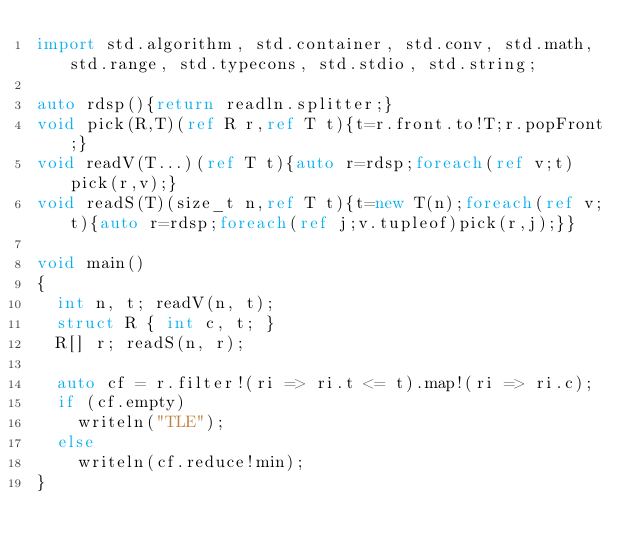<code> <loc_0><loc_0><loc_500><loc_500><_D_>import std.algorithm, std.container, std.conv, std.math, std.range, std.typecons, std.stdio, std.string;

auto rdsp(){return readln.splitter;}
void pick(R,T)(ref R r,ref T t){t=r.front.to!T;r.popFront;}
void readV(T...)(ref T t){auto r=rdsp;foreach(ref v;t)pick(r,v);}
void readS(T)(size_t n,ref T t){t=new T(n);foreach(ref v;t){auto r=rdsp;foreach(ref j;v.tupleof)pick(r,j);}}

void main()
{
  int n, t; readV(n, t);
  struct R { int c, t; }
  R[] r; readS(n, r);

  auto cf = r.filter!(ri => ri.t <= t).map!(ri => ri.c);
  if (cf.empty)
    writeln("TLE");
  else
    writeln(cf.reduce!min);
}
</code> 